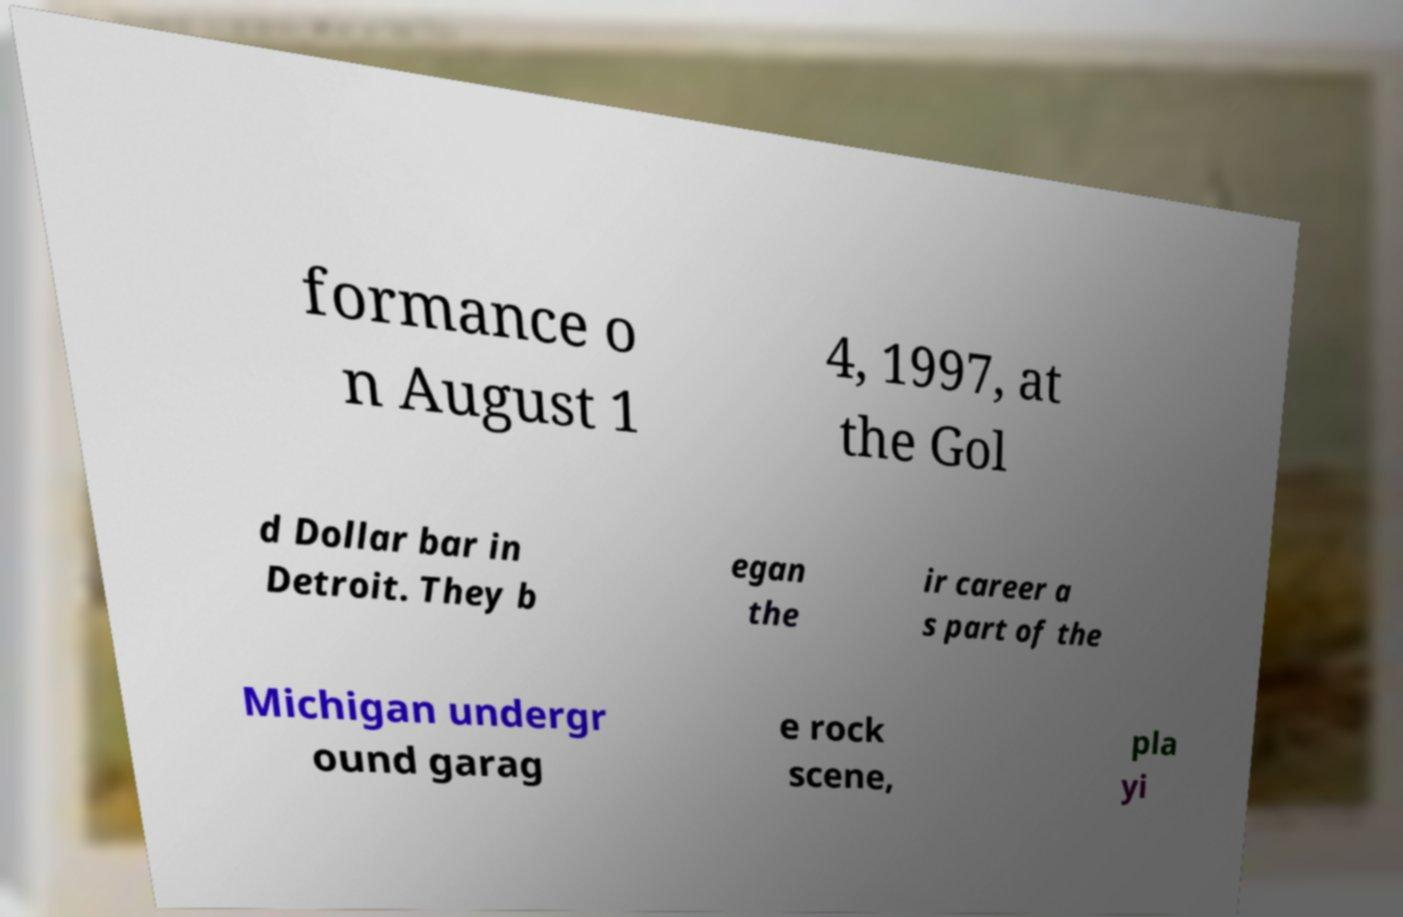I need the written content from this picture converted into text. Can you do that? formance o n August 1 4, 1997, at the Gol d Dollar bar in Detroit. They b egan the ir career a s part of the Michigan undergr ound garag e rock scene, pla yi 